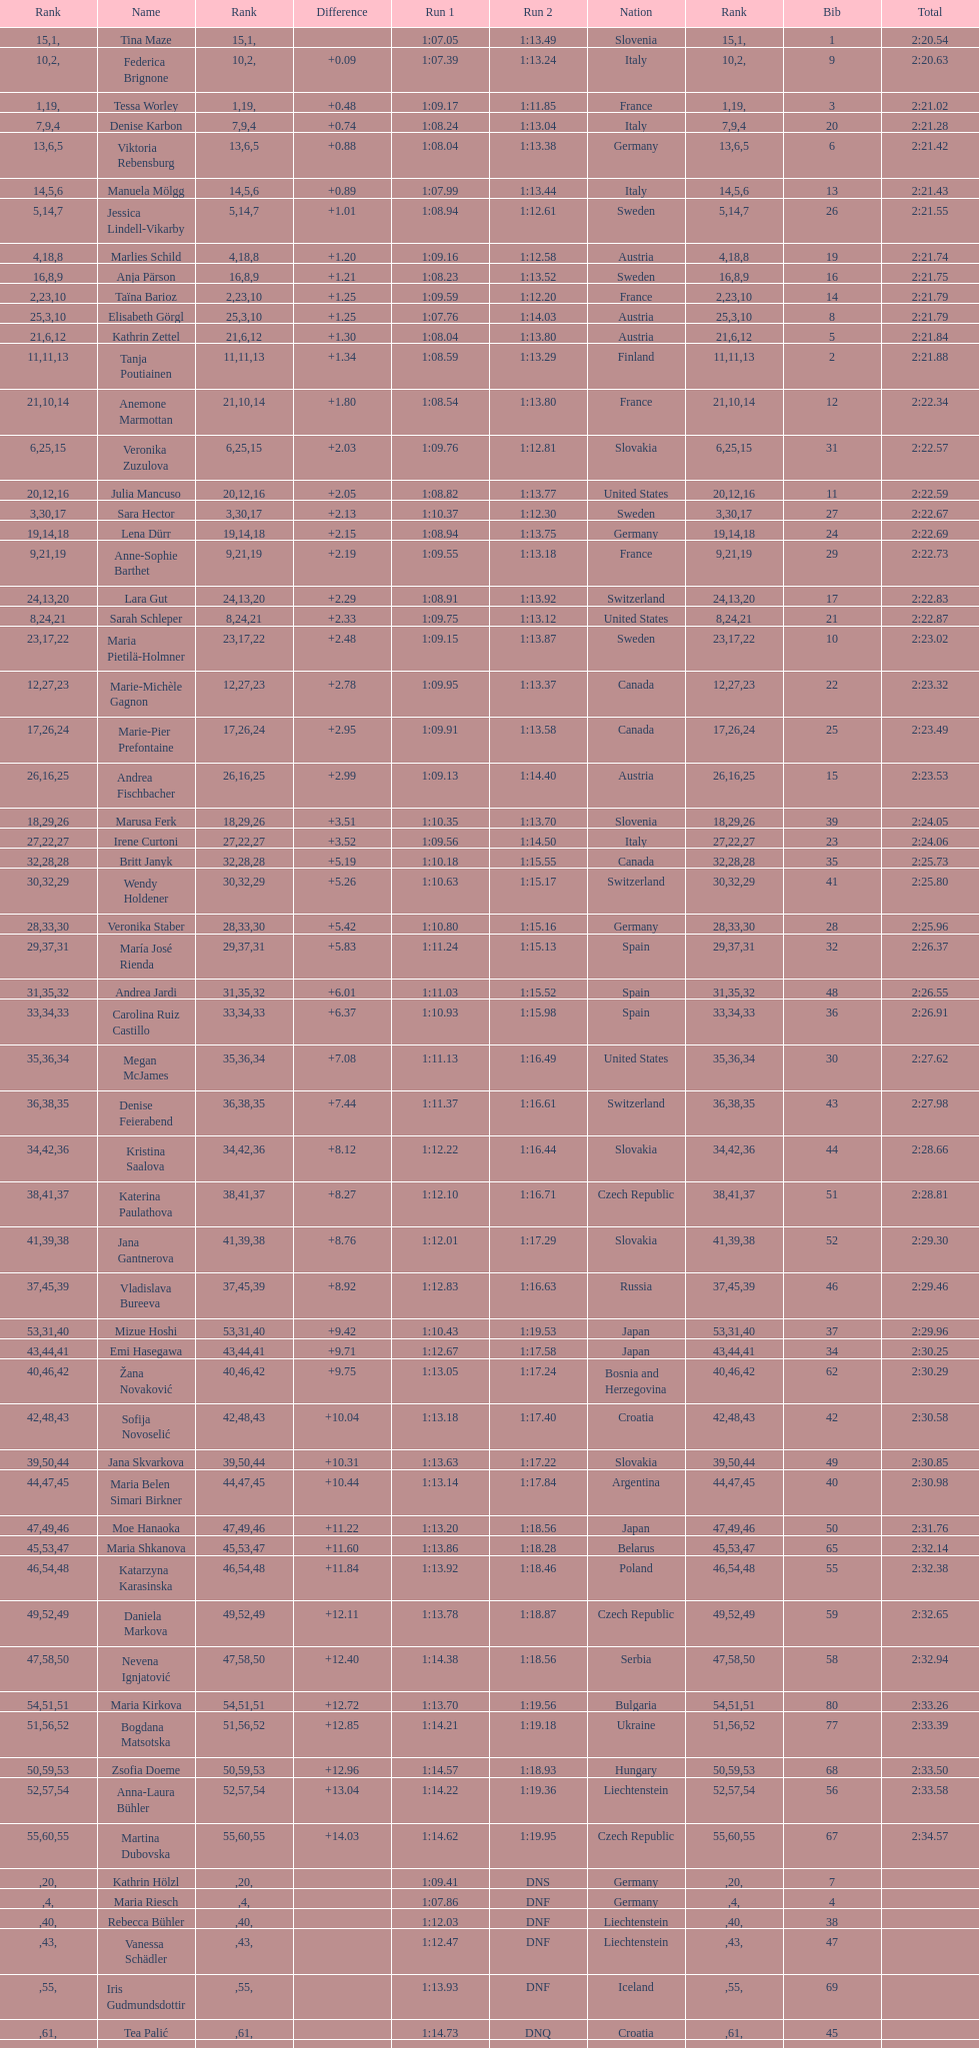How many italians finished in the top ten? 3. 